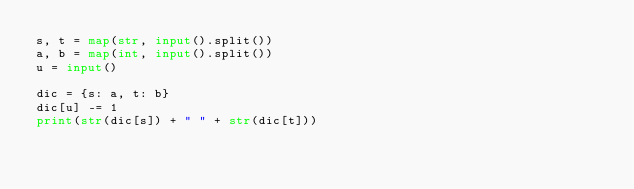<code> <loc_0><loc_0><loc_500><loc_500><_Python_>s, t = map(str, input().split())
a, b = map(int, input().split())
u = input()

dic = {s: a, t: b}
dic[u] -= 1
print(str(dic[s]) + " " + str(dic[t]))</code> 